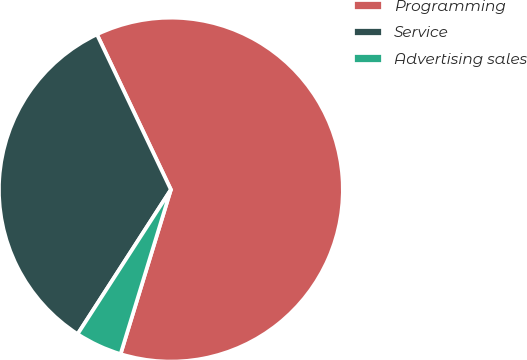Convert chart to OTSL. <chart><loc_0><loc_0><loc_500><loc_500><pie_chart><fcel>Programming<fcel>Service<fcel>Advertising sales<nl><fcel>61.8%<fcel>33.8%<fcel>4.4%<nl></chart> 